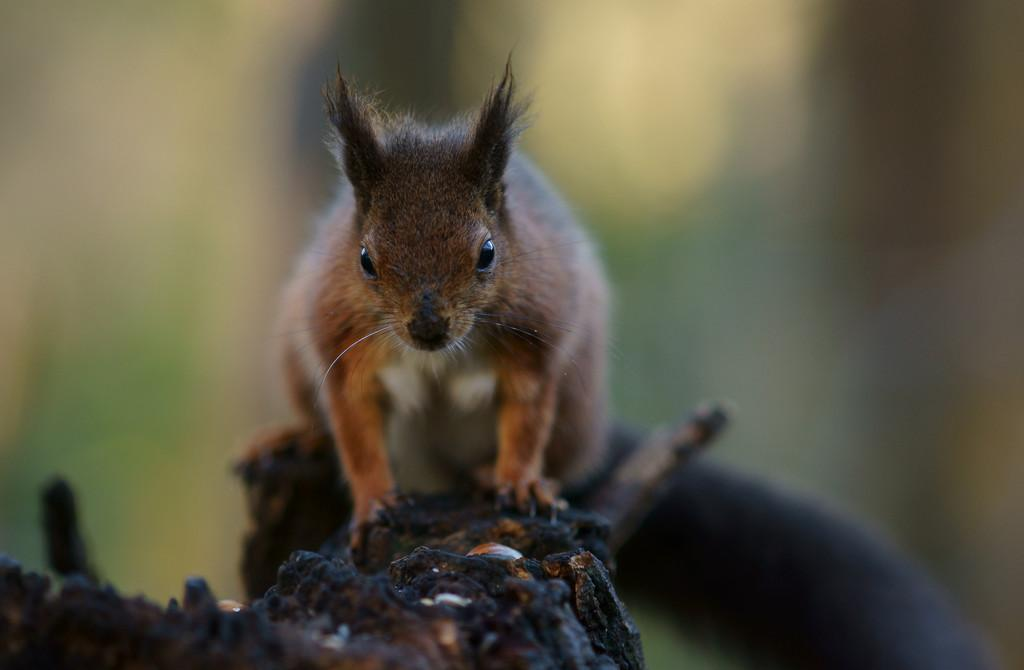What type of animal is in the image? There is a fox squirrel in the image. What is the fox squirrel standing on? The fox squirrel is on a wooden surface. Can you describe the background of the image? The background of the image is blurred. What list of items can be seen in the image? There is no list of items present in the image; it features a fox squirrel on a wooden surface with a blurred background. 